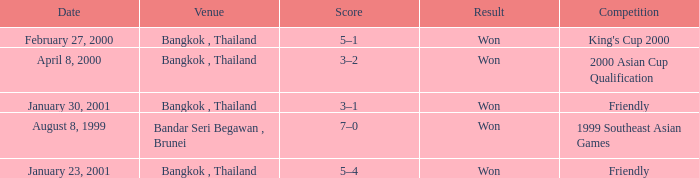What was the result of the game that was played on february 27, 2000? Won. 